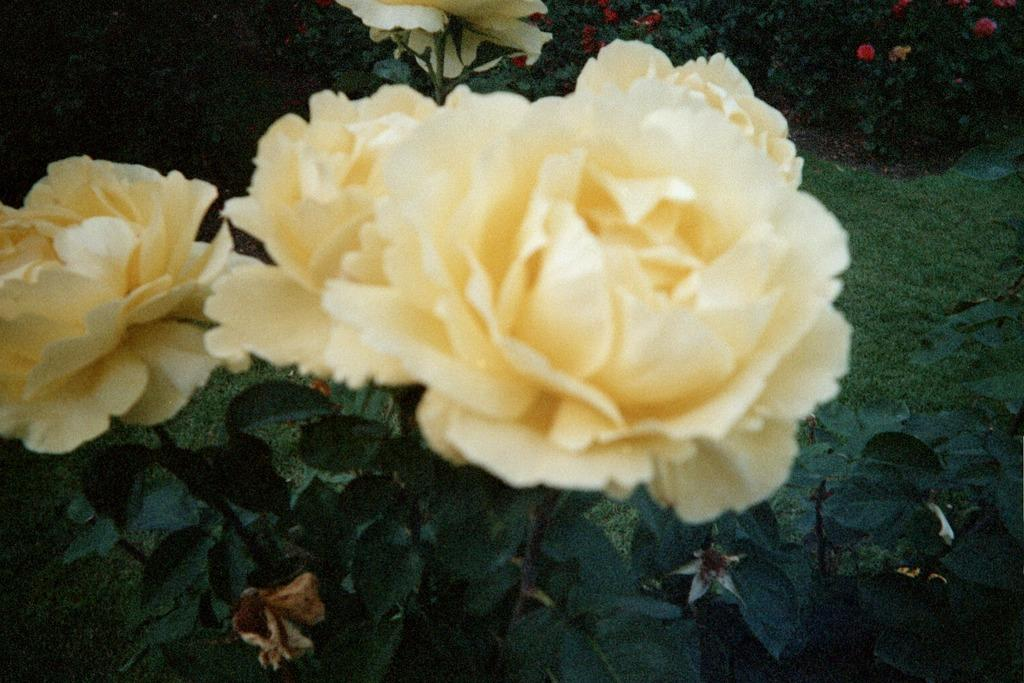What type of flowers are in the image? There are rose flowers in the image. What is the source of the rose flowers in the image? There is a rose plant in the image. What else can be seen on the rose plant besides the flowers? Rose leaves are visible in the image. Where is the image set? The image is set in a garden. What can be seen in the background of the image? There are plants visible in the background of the image. What type of camp can be seen in the image? There is no camp present in the image; it features rose flowers, a rose plant, and plants in the background. What finger is holding the rose flower in the image? There are no fingers holding the rose flower in the image; it is a still image of the plant and flowers. 